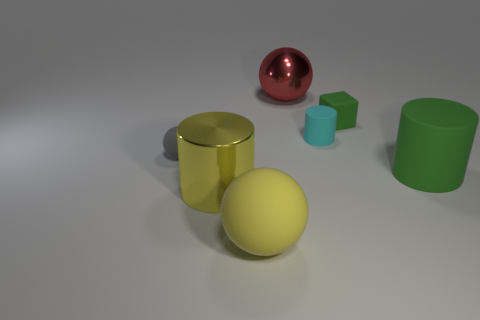Is there anything else that is the same shape as the tiny green object?
Give a very brief answer. No. There is a object that is the same color as the metallic cylinder; what is it made of?
Ensure brevity in your answer.  Rubber. Is the color of the shiny cylinder the same as the small cube?
Provide a short and direct response. No. What is the color of the large sphere that is behind the tiny cyan cylinder?
Ensure brevity in your answer.  Red. Is there a small gray object that has the same shape as the red thing?
Your answer should be very brief. Yes. How many red objects are either tiny rubber blocks or metal spheres?
Your answer should be compact. 1. Is there a purple thing that has the same size as the gray rubber object?
Your response must be concise. No. How many tiny gray objects are there?
Your answer should be very brief. 1. What number of big objects are either red objects or green rubber things?
Provide a short and direct response. 2. The matte sphere that is behind the large cylinder on the right side of the metal object to the left of the large metallic sphere is what color?
Give a very brief answer. Gray. 